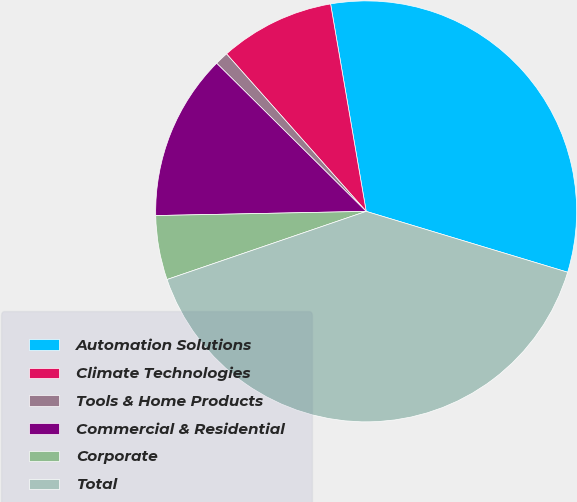Convert chart. <chart><loc_0><loc_0><loc_500><loc_500><pie_chart><fcel>Automation Solutions<fcel>Climate Technologies<fcel>Tools & Home Products<fcel>Commercial & Residential<fcel>Corporate<fcel>Total<nl><fcel>32.37%<fcel>8.84%<fcel>1.03%<fcel>12.74%<fcel>4.93%<fcel>40.08%<nl></chart> 